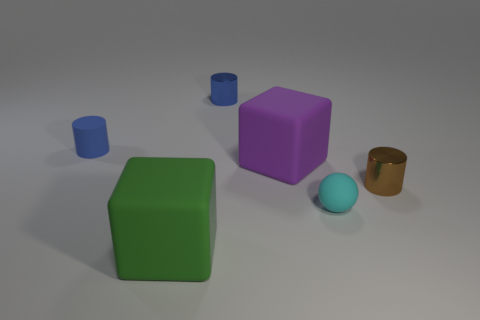Subtract all small brown cylinders. How many cylinders are left? 2 Add 4 small cyan cylinders. How many objects exist? 10 Subtract all cyan cubes. How many blue cylinders are left? 2 Subtract all blue cylinders. How many cylinders are left? 1 Subtract all brown balls. Subtract all cyan blocks. How many balls are left? 1 Add 3 blue metal things. How many blue metal things are left? 4 Add 4 green matte objects. How many green matte objects exist? 5 Subtract 0 blue blocks. How many objects are left? 6 Subtract all cubes. How many objects are left? 4 Subtract all metal cylinders. Subtract all small yellow cubes. How many objects are left? 4 